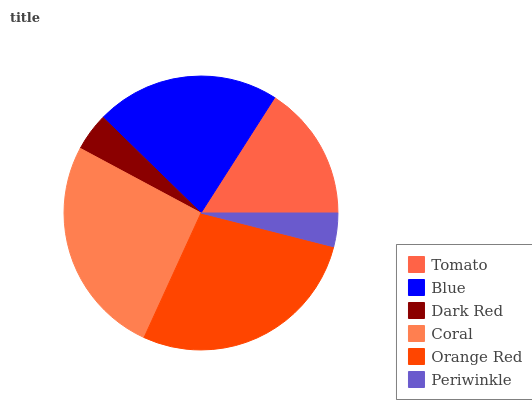Is Periwinkle the minimum?
Answer yes or no. Yes. Is Orange Red the maximum?
Answer yes or no. Yes. Is Blue the minimum?
Answer yes or no. No. Is Blue the maximum?
Answer yes or no. No. Is Blue greater than Tomato?
Answer yes or no. Yes. Is Tomato less than Blue?
Answer yes or no. Yes. Is Tomato greater than Blue?
Answer yes or no. No. Is Blue less than Tomato?
Answer yes or no. No. Is Blue the high median?
Answer yes or no. Yes. Is Tomato the low median?
Answer yes or no. Yes. Is Coral the high median?
Answer yes or no. No. Is Blue the low median?
Answer yes or no. No. 